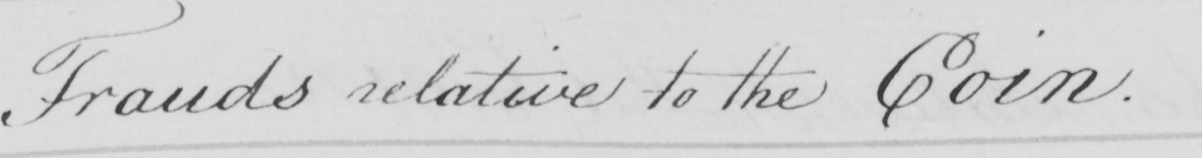What text is written in this handwritten line? Frauds relative to the Coin . 